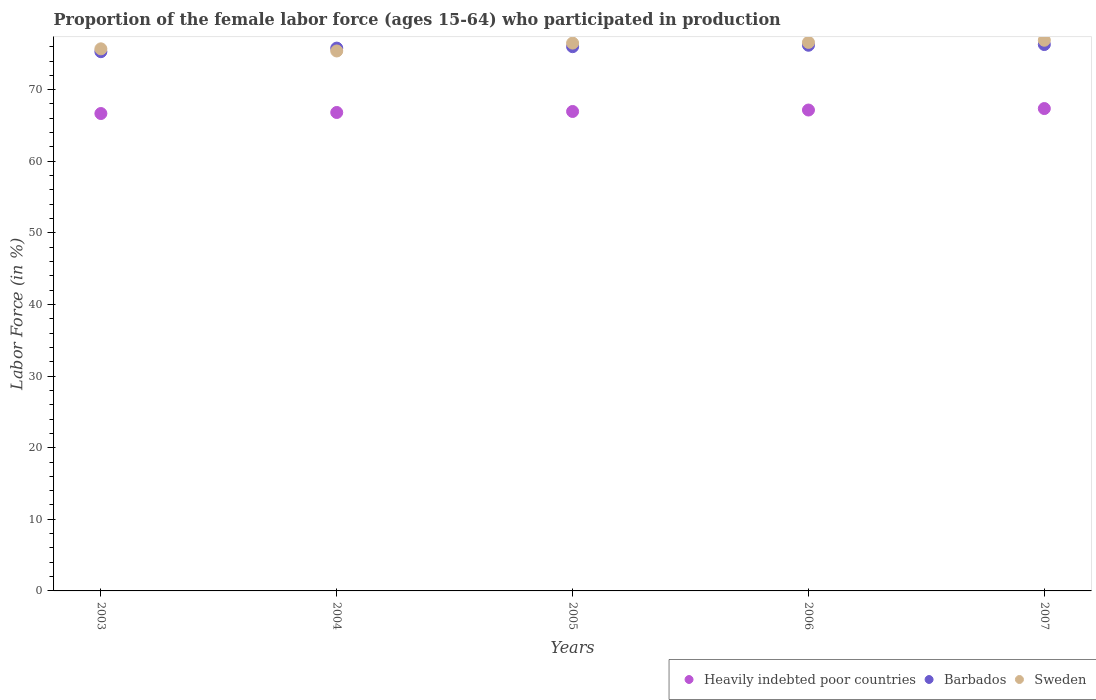What is the proportion of the female labor force who participated in production in Barbados in 2006?
Keep it short and to the point. 76.2. Across all years, what is the maximum proportion of the female labor force who participated in production in Heavily indebted poor countries?
Your answer should be compact. 67.36. Across all years, what is the minimum proportion of the female labor force who participated in production in Barbados?
Your answer should be very brief. 75.3. In which year was the proportion of the female labor force who participated in production in Sweden maximum?
Ensure brevity in your answer.  2007. What is the total proportion of the female labor force who participated in production in Sweden in the graph?
Give a very brief answer. 381.1. What is the difference between the proportion of the female labor force who participated in production in Heavily indebted poor countries in 2005 and that in 2007?
Provide a short and direct response. -0.41. What is the difference between the proportion of the female labor force who participated in production in Heavily indebted poor countries in 2006 and the proportion of the female labor force who participated in production in Barbados in 2007?
Offer a very short reply. -9.15. What is the average proportion of the female labor force who participated in production in Sweden per year?
Your response must be concise. 76.22. In the year 2007, what is the difference between the proportion of the female labor force who participated in production in Sweden and proportion of the female labor force who participated in production in Heavily indebted poor countries?
Offer a terse response. 9.54. What is the ratio of the proportion of the female labor force who participated in production in Barbados in 2006 to that in 2007?
Your response must be concise. 1. Is the difference between the proportion of the female labor force who participated in production in Sweden in 2003 and 2006 greater than the difference between the proportion of the female labor force who participated in production in Heavily indebted poor countries in 2003 and 2006?
Your response must be concise. No. What is the difference between the highest and the second highest proportion of the female labor force who participated in production in Sweden?
Make the answer very short. 0.3. In how many years, is the proportion of the female labor force who participated in production in Barbados greater than the average proportion of the female labor force who participated in production in Barbados taken over all years?
Offer a terse response. 3. Is the sum of the proportion of the female labor force who participated in production in Barbados in 2004 and 2006 greater than the maximum proportion of the female labor force who participated in production in Sweden across all years?
Make the answer very short. Yes. Is it the case that in every year, the sum of the proportion of the female labor force who participated in production in Sweden and proportion of the female labor force who participated in production in Heavily indebted poor countries  is greater than the proportion of the female labor force who participated in production in Barbados?
Keep it short and to the point. Yes. Is the proportion of the female labor force who participated in production in Sweden strictly greater than the proportion of the female labor force who participated in production in Barbados over the years?
Provide a short and direct response. No. Is the proportion of the female labor force who participated in production in Heavily indebted poor countries strictly less than the proportion of the female labor force who participated in production in Barbados over the years?
Make the answer very short. Yes. How many years are there in the graph?
Offer a very short reply. 5. What is the difference between two consecutive major ticks on the Y-axis?
Your answer should be very brief. 10. Are the values on the major ticks of Y-axis written in scientific E-notation?
Provide a succinct answer. No. Where does the legend appear in the graph?
Your answer should be very brief. Bottom right. What is the title of the graph?
Your response must be concise. Proportion of the female labor force (ages 15-64) who participated in production. Does "United Arab Emirates" appear as one of the legend labels in the graph?
Offer a very short reply. No. What is the label or title of the Y-axis?
Offer a terse response. Labor Force (in %). What is the Labor Force (in %) in Heavily indebted poor countries in 2003?
Provide a succinct answer. 66.67. What is the Labor Force (in %) in Barbados in 2003?
Ensure brevity in your answer.  75.3. What is the Labor Force (in %) in Sweden in 2003?
Provide a short and direct response. 75.7. What is the Labor Force (in %) in Heavily indebted poor countries in 2004?
Offer a terse response. 66.81. What is the Labor Force (in %) of Barbados in 2004?
Give a very brief answer. 75.8. What is the Labor Force (in %) of Sweden in 2004?
Your answer should be compact. 75.4. What is the Labor Force (in %) in Heavily indebted poor countries in 2005?
Provide a succinct answer. 66.95. What is the Labor Force (in %) of Barbados in 2005?
Provide a succinct answer. 76. What is the Labor Force (in %) of Sweden in 2005?
Your answer should be compact. 76.5. What is the Labor Force (in %) of Heavily indebted poor countries in 2006?
Provide a short and direct response. 67.15. What is the Labor Force (in %) of Barbados in 2006?
Keep it short and to the point. 76.2. What is the Labor Force (in %) in Sweden in 2006?
Make the answer very short. 76.6. What is the Labor Force (in %) of Heavily indebted poor countries in 2007?
Provide a succinct answer. 67.36. What is the Labor Force (in %) in Barbados in 2007?
Offer a very short reply. 76.3. What is the Labor Force (in %) of Sweden in 2007?
Your answer should be compact. 76.9. Across all years, what is the maximum Labor Force (in %) in Heavily indebted poor countries?
Your response must be concise. 67.36. Across all years, what is the maximum Labor Force (in %) in Barbados?
Your answer should be compact. 76.3. Across all years, what is the maximum Labor Force (in %) in Sweden?
Give a very brief answer. 76.9. Across all years, what is the minimum Labor Force (in %) of Heavily indebted poor countries?
Your answer should be very brief. 66.67. Across all years, what is the minimum Labor Force (in %) of Barbados?
Offer a terse response. 75.3. Across all years, what is the minimum Labor Force (in %) of Sweden?
Provide a short and direct response. 75.4. What is the total Labor Force (in %) of Heavily indebted poor countries in the graph?
Your answer should be very brief. 334.95. What is the total Labor Force (in %) of Barbados in the graph?
Ensure brevity in your answer.  379.6. What is the total Labor Force (in %) in Sweden in the graph?
Keep it short and to the point. 381.1. What is the difference between the Labor Force (in %) of Heavily indebted poor countries in 2003 and that in 2004?
Give a very brief answer. -0.15. What is the difference between the Labor Force (in %) in Barbados in 2003 and that in 2004?
Your answer should be compact. -0.5. What is the difference between the Labor Force (in %) in Sweden in 2003 and that in 2004?
Your response must be concise. 0.3. What is the difference between the Labor Force (in %) in Heavily indebted poor countries in 2003 and that in 2005?
Keep it short and to the point. -0.29. What is the difference between the Labor Force (in %) of Barbados in 2003 and that in 2005?
Provide a short and direct response. -0.7. What is the difference between the Labor Force (in %) of Sweden in 2003 and that in 2005?
Your response must be concise. -0.8. What is the difference between the Labor Force (in %) in Heavily indebted poor countries in 2003 and that in 2006?
Offer a very short reply. -0.49. What is the difference between the Labor Force (in %) of Barbados in 2003 and that in 2006?
Your response must be concise. -0.9. What is the difference between the Labor Force (in %) of Sweden in 2003 and that in 2006?
Your response must be concise. -0.9. What is the difference between the Labor Force (in %) of Heavily indebted poor countries in 2003 and that in 2007?
Give a very brief answer. -0.69. What is the difference between the Labor Force (in %) of Heavily indebted poor countries in 2004 and that in 2005?
Make the answer very short. -0.14. What is the difference between the Labor Force (in %) in Barbados in 2004 and that in 2005?
Your answer should be compact. -0.2. What is the difference between the Labor Force (in %) of Sweden in 2004 and that in 2005?
Give a very brief answer. -1.1. What is the difference between the Labor Force (in %) in Heavily indebted poor countries in 2004 and that in 2006?
Make the answer very short. -0.34. What is the difference between the Labor Force (in %) of Barbados in 2004 and that in 2006?
Your answer should be compact. -0.4. What is the difference between the Labor Force (in %) in Sweden in 2004 and that in 2006?
Make the answer very short. -1.2. What is the difference between the Labor Force (in %) in Heavily indebted poor countries in 2004 and that in 2007?
Provide a succinct answer. -0.55. What is the difference between the Labor Force (in %) of Sweden in 2004 and that in 2007?
Your answer should be very brief. -1.5. What is the difference between the Labor Force (in %) of Heavily indebted poor countries in 2005 and that in 2006?
Keep it short and to the point. -0.2. What is the difference between the Labor Force (in %) of Barbados in 2005 and that in 2006?
Keep it short and to the point. -0.2. What is the difference between the Labor Force (in %) in Sweden in 2005 and that in 2006?
Keep it short and to the point. -0.1. What is the difference between the Labor Force (in %) in Heavily indebted poor countries in 2005 and that in 2007?
Give a very brief answer. -0.41. What is the difference between the Labor Force (in %) of Barbados in 2005 and that in 2007?
Provide a succinct answer. -0.3. What is the difference between the Labor Force (in %) of Heavily indebted poor countries in 2006 and that in 2007?
Provide a short and direct response. -0.21. What is the difference between the Labor Force (in %) of Barbados in 2006 and that in 2007?
Make the answer very short. -0.1. What is the difference between the Labor Force (in %) in Heavily indebted poor countries in 2003 and the Labor Force (in %) in Barbados in 2004?
Provide a succinct answer. -9.13. What is the difference between the Labor Force (in %) of Heavily indebted poor countries in 2003 and the Labor Force (in %) of Sweden in 2004?
Your response must be concise. -8.73. What is the difference between the Labor Force (in %) of Heavily indebted poor countries in 2003 and the Labor Force (in %) of Barbados in 2005?
Offer a very short reply. -9.33. What is the difference between the Labor Force (in %) in Heavily indebted poor countries in 2003 and the Labor Force (in %) in Sweden in 2005?
Provide a short and direct response. -9.83. What is the difference between the Labor Force (in %) of Barbados in 2003 and the Labor Force (in %) of Sweden in 2005?
Your answer should be compact. -1.2. What is the difference between the Labor Force (in %) of Heavily indebted poor countries in 2003 and the Labor Force (in %) of Barbados in 2006?
Give a very brief answer. -9.53. What is the difference between the Labor Force (in %) in Heavily indebted poor countries in 2003 and the Labor Force (in %) in Sweden in 2006?
Your response must be concise. -9.93. What is the difference between the Labor Force (in %) in Barbados in 2003 and the Labor Force (in %) in Sweden in 2006?
Offer a very short reply. -1.3. What is the difference between the Labor Force (in %) of Heavily indebted poor countries in 2003 and the Labor Force (in %) of Barbados in 2007?
Your answer should be compact. -9.63. What is the difference between the Labor Force (in %) in Heavily indebted poor countries in 2003 and the Labor Force (in %) in Sweden in 2007?
Provide a succinct answer. -10.23. What is the difference between the Labor Force (in %) in Barbados in 2003 and the Labor Force (in %) in Sweden in 2007?
Provide a succinct answer. -1.6. What is the difference between the Labor Force (in %) in Heavily indebted poor countries in 2004 and the Labor Force (in %) in Barbados in 2005?
Give a very brief answer. -9.19. What is the difference between the Labor Force (in %) of Heavily indebted poor countries in 2004 and the Labor Force (in %) of Sweden in 2005?
Offer a very short reply. -9.69. What is the difference between the Labor Force (in %) of Barbados in 2004 and the Labor Force (in %) of Sweden in 2005?
Your response must be concise. -0.7. What is the difference between the Labor Force (in %) in Heavily indebted poor countries in 2004 and the Labor Force (in %) in Barbados in 2006?
Provide a succinct answer. -9.39. What is the difference between the Labor Force (in %) in Heavily indebted poor countries in 2004 and the Labor Force (in %) in Sweden in 2006?
Your answer should be very brief. -9.79. What is the difference between the Labor Force (in %) in Barbados in 2004 and the Labor Force (in %) in Sweden in 2006?
Make the answer very short. -0.8. What is the difference between the Labor Force (in %) in Heavily indebted poor countries in 2004 and the Labor Force (in %) in Barbados in 2007?
Your answer should be compact. -9.49. What is the difference between the Labor Force (in %) in Heavily indebted poor countries in 2004 and the Labor Force (in %) in Sweden in 2007?
Your answer should be very brief. -10.09. What is the difference between the Labor Force (in %) in Heavily indebted poor countries in 2005 and the Labor Force (in %) in Barbados in 2006?
Provide a short and direct response. -9.25. What is the difference between the Labor Force (in %) in Heavily indebted poor countries in 2005 and the Labor Force (in %) in Sweden in 2006?
Make the answer very short. -9.65. What is the difference between the Labor Force (in %) in Heavily indebted poor countries in 2005 and the Labor Force (in %) in Barbados in 2007?
Give a very brief answer. -9.35. What is the difference between the Labor Force (in %) in Heavily indebted poor countries in 2005 and the Labor Force (in %) in Sweden in 2007?
Your response must be concise. -9.95. What is the difference between the Labor Force (in %) in Heavily indebted poor countries in 2006 and the Labor Force (in %) in Barbados in 2007?
Offer a terse response. -9.15. What is the difference between the Labor Force (in %) in Heavily indebted poor countries in 2006 and the Labor Force (in %) in Sweden in 2007?
Offer a very short reply. -9.75. What is the average Labor Force (in %) of Heavily indebted poor countries per year?
Ensure brevity in your answer.  66.99. What is the average Labor Force (in %) in Barbados per year?
Offer a terse response. 75.92. What is the average Labor Force (in %) of Sweden per year?
Your response must be concise. 76.22. In the year 2003, what is the difference between the Labor Force (in %) of Heavily indebted poor countries and Labor Force (in %) of Barbados?
Your answer should be compact. -8.63. In the year 2003, what is the difference between the Labor Force (in %) in Heavily indebted poor countries and Labor Force (in %) in Sweden?
Your answer should be very brief. -9.03. In the year 2003, what is the difference between the Labor Force (in %) in Barbados and Labor Force (in %) in Sweden?
Make the answer very short. -0.4. In the year 2004, what is the difference between the Labor Force (in %) in Heavily indebted poor countries and Labor Force (in %) in Barbados?
Your response must be concise. -8.99. In the year 2004, what is the difference between the Labor Force (in %) of Heavily indebted poor countries and Labor Force (in %) of Sweden?
Your answer should be compact. -8.59. In the year 2004, what is the difference between the Labor Force (in %) of Barbados and Labor Force (in %) of Sweden?
Offer a very short reply. 0.4. In the year 2005, what is the difference between the Labor Force (in %) in Heavily indebted poor countries and Labor Force (in %) in Barbados?
Your answer should be very brief. -9.05. In the year 2005, what is the difference between the Labor Force (in %) of Heavily indebted poor countries and Labor Force (in %) of Sweden?
Your answer should be very brief. -9.55. In the year 2006, what is the difference between the Labor Force (in %) in Heavily indebted poor countries and Labor Force (in %) in Barbados?
Keep it short and to the point. -9.05. In the year 2006, what is the difference between the Labor Force (in %) of Heavily indebted poor countries and Labor Force (in %) of Sweden?
Your answer should be very brief. -9.45. In the year 2006, what is the difference between the Labor Force (in %) of Barbados and Labor Force (in %) of Sweden?
Provide a succinct answer. -0.4. In the year 2007, what is the difference between the Labor Force (in %) of Heavily indebted poor countries and Labor Force (in %) of Barbados?
Provide a short and direct response. -8.94. In the year 2007, what is the difference between the Labor Force (in %) in Heavily indebted poor countries and Labor Force (in %) in Sweden?
Keep it short and to the point. -9.54. What is the ratio of the Labor Force (in %) of Heavily indebted poor countries in 2003 to that in 2004?
Give a very brief answer. 1. What is the ratio of the Labor Force (in %) of Barbados in 2003 to that in 2004?
Your answer should be very brief. 0.99. What is the ratio of the Labor Force (in %) in Barbados in 2003 to that in 2005?
Make the answer very short. 0.99. What is the ratio of the Labor Force (in %) of Sweden in 2003 to that in 2005?
Provide a short and direct response. 0.99. What is the ratio of the Labor Force (in %) in Barbados in 2003 to that in 2006?
Keep it short and to the point. 0.99. What is the ratio of the Labor Force (in %) of Sweden in 2003 to that in 2006?
Offer a very short reply. 0.99. What is the ratio of the Labor Force (in %) of Barbados in 2003 to that in 2007?
Provide a succinct answer. 0.99. What is the ratio of the Labor Force (in %) of Sweden in 2003 to that in 2007?
Make the answer very short. 0.98. What is the ratio of the Labor Force (in %) of Heavily indebted poor countries in 2004 to that in 2005?
Keep it short and to the point. 1. What is the ratio of the Labor Force (in %) of Sweden in 2004 to that in 2005?
Keep it short and to the point. 0.99. What is the ratio of the Labor Force (in %) in Sweden in 2004 to that in 2006?
Offer a terse response. 0.98. What is the ratio of the Labor Force (in %) in Barbados in 2004 to that in 2007?
Keep it short and to the point. 0.99. What is the ratio of the Labor Force (in %) in Sweden in 2004 to that in 2007?
Ensure brevity in your answer.  0.98. What is the ratio of the Labor Force (in %) in Heavily indebted poor countries in 2005 to that in 2007?
Provide a short and direct response. 0.99. What is the ratio of the Labor Force (in %) in Barbados in 2005 to that in 2007?
Give a very brief answer. 1. What is the ratio of the Labor Force (in %) of Heavily indebted poor countries in 2006 to that in 2007?
Ensure brevity in your answer.  1. What is the ratio of the Labor Force (in %) of Sweden in 2006 to that in 2007?
Ensure brevity in your answer.  1. What is the difference between the highest and the second highest Labor Force (in %) of Heavily indebted poor countries?
Provide a succinct answer. 0.21. What is the difference between the highest and the second highest Labor Force (in %) of Sweden?
Offer a terse response. 0.3. What is the difference between the highest and the lowest Labor Force (in %) in Heavily indebted poor countries?
Offer a very short reply. 0.69. What is the difference between the highest and the lowest Labor Force (in %) of Barbados?
Make the answer very short. 1. What is the difference between the highest and the lowest Labor Force (in %) of Sweden?
Provide a succinct answer. 1.5. 